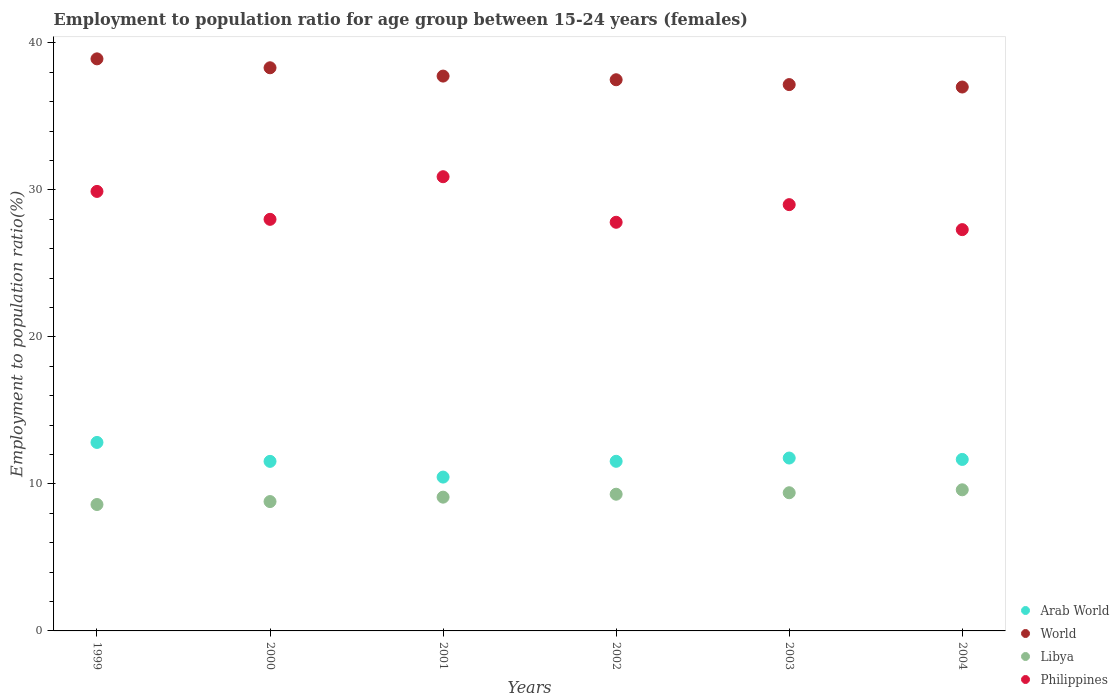Is the number of dotlines equal to the number of legend labels?
Give a very brief answer. Yes. What is the employment to population ratio in World in 2001?
Make the answer very short. 37.75. Across all years, what is the maximum employment to population ratio in Philippines?
Offer a very short reply. 30.9. Across all years, what is the minimum employment to population ratio in Philippines?
Make the answer very short. 27.3. In which year was the employment to population ratio in World maximum?
Your answer should be very brief. 1999. What is the total employment to population ratio in Libya in the graph?
Provide a short and direct response. 54.8. What is the difference between the employment to population ratio in Philippines in 2000 and that in 2004?
Offer a terse response. 0.7. What is the difference between the employment to population ratio in Libya in 2004 and the employment to population ratio in Philippines in 2003?
Give a very brief answer. -19.4. What is the average employment to population ratio in Arab World per year?
Your answer should be very brief. 11.63. In the year 2000, what is the difference between the employment to population ratio in World and employment to population ratio in Libya?
Offer a terse response. 29.51. In how many years, is the employment to population ratio in World greater than 4 %?
Keep it short and to the point. 6. What is the ratio of the employment to population ratio in Arab World in 2002 to that in 2004?
Your response must be concise. 0.99. Is the employment to population ratio in World in 1999 less than that in 2004?
Provide a succinct answer. No. Is the difference between the employment to population ratio in World in 1999 and 2004 greater than the difference between the employment to population ratio in Libya in 1999 and 2004?
Provide a succinct answer. Yes. What is the difference between the highest and the second highest employment to population ratio in World?
Keep it short and to the point. 0.61. What is the difference between the highest and the lowest employment to population ratio in Libya?
Give a very brief answer. 1. Is it the case that in every year, the sum of the employment to population ratio in Philippines and employment to population ratio in Libya  is greater than the employment to population ratio in World?
Offer a terse response. No. Does the employment to population ratio in Philippines monotonically increase over the years?
Ensure brevity in your answer.  No. Is the employment to population ratio in Libya strictly less than the employment to population ratio in World over the years?
Offer a very short reply. Yes. How many dotlines are there?
Ensure brevity in your answer.  4. Are the values on the major ticks of Y-axis written in scientific E-notation?
Keep it short and to the point. No. Does the graph contain any zero values?
Provide a short and direct response. No. Does the graph contain grids?
Provide a succinct answer. No. How many legend labels are there?
Provide a succinct answer. 4. What is the title of the graph?
Give a very brief answer. Employment to population ratio for age group between 15-24 years (females). What is the label or title of the X-axis?
Offer a very short reply. Years. What is the Employment to population ratio(%) in Arab World in 1999?
Ensure brevity in your answer.  12.82. What is the Employment to population ratio(%) of World in 1999?
Provide a succinct answer. 38.92. What is the Employment to population ratio(%) of Libya in 1999?
Ensure brevity in your answer.  8.6. What is the Employment to population ratio(%) of Philippines in 1999?
Your answer should be compact. 29.9. What is the Employment to population ratio(%) in Arab World in 2000?
Offer a terse response. 11.53. What is the Employment to population ratio(%) in World in 2000?
Your answer should be compact. 38.31. What is the Employment to population ratio(%) of Libya in 2000?
Provide a short and direct response. 8.8. What is the Employment to population ratio(%) in Philippines in 2000?
Keep it short and to the point. 28. What is the Employment to population ratio(%) in Arab World in 2001?
Make the answer very short. 10.47. What is the Employment to population ratio(%) in World in 2001?
Provide a succinct answer. 37.75. What is the Employment to population ratio(%) in Libya in 2001?
Your response must be concise. 9.1. What is the Employment to population ratio(%) in Philippines in 2001?
Offer a terse response. 30.9. What is the Employment to population ratio(%) in Arab World in 2002?
Give a very brief answer. 11.54. What is the Employment to population ratio(%) in World in 2002?
Offer a terse response. 37.5. What is the Employment to population ratio(%) of Libya in 2002?
Offer a very short reply. 9.3. What is the Employment to population ratio(%) of Philippines in 2002?
Offer a very short reply. 27.8. What is the Employment to population ratio(%) in Arab World in 2003?
Keep it short and to the point. 11.76. What is the Employment to population ratio(%) of World in 2003?
Keep it short and to the point. 37.17. What is the Employment to population ratio(%) of Libya in 2003?
Provide a succinct answer. 9.4. What is the Employment to population ratio(%) in Arab World in 2004?
Offer a terse response. 11.67. What is the Employment to population ratio(%) of World in 2004?
Provide a short and direct response. 37. What is the Employment to population ratio(%) in Libya in 2004?
Provide a short and direct response. 9.6. What is the Employment to population ratio(%) of Philippines in 2004?
Provide a succinct answer. 27.3. Across all years, what is the maximum Employment to population ratio(%) of Arab World?
Ensure brevity in your answer.  12.82. Across all years, what is the maximum Employment to population ratio(%) of World?
Provide a succinct answer. 38.92. Across all years, what is the maximum Employment to population ratio(%) in Libya?
Provide a succinct answer. 9.6. Across all years, what is the maximum Employment to population ratio(%) in Philippines?
Your response must be concise. 30.9. Across all years, what is the minimum Employment to population ratio(%) of Arab World?
Make the answer very short. 10.47. Across all years, what is the minimum Employment to population ratio(%) in World?
Your answer should be very brief. 37. Across all years, what is the minimum Employment to population ratio(%) of Libya?
Make the answer very short. 8.6. Across all years, what is the minimum Employment to population ratio(%) of Philippines?
Provide a succinct answer. 27.3. What is the total Employment to population ratio(%) of Arab World in the graph?
Your response must be concise. 69.79. What is the total Employment to population ratio(%) in World in the graph?
Make the answer very short. 226.64. What is the total Employment to population ratio(%) in Libya in the graph?
Ensure brevity in your answer.  54.8. What is the total Employment to population ratio(%) in Philippines in the graph?
Offer a very short reply. 172.9. What is the difference between the Employment to population ratio(%) of Arab World in 1999 and that in 2000?
Give a very brief answer. 1.29. What is the difference between the Employment to population ratio(%) in World in 1999 and that in 2000?
Your answer should be compact. 0.61. What is the difference between the Employment to population ratio(%) of Arab World in 1999 and that in 2001?
Your answer should be very brief. 2.36. What is the difference between the Employment to population ratio(%) in World in 1999 and that in 2001?
Your response must be concise. 1.17. What is the difference between the Employment to population ratio(%) of Arab World in 1999 and that in 2002?
Give a very brief answer. 1.28. What is the difference between the Employment to population ratio(%) of World in 1999 and that in 2002?
Offer a terse response. 1.42. What is the difference between the Employment to population ratio(%) in Libya in 1999 and that in 2002?
Ensure brevity in your answer.  -0.7. What is the difference between the Employment to population ratio(%) in Arab World in 1999 and that in 2003?
Ensure brevity in your answer.  1.06. What is the difference between the Employment to population ratio(%) of World in 1999 and that in 2003?
Keep it short and to the point. 1.75. What is the difference between the Employment to population ratio(%) of Arab World in 1999 and that in 2004?
Offer a terse response. 1.16. What is the difference between the Employment to population ratio(%) in World in 1999 and that in 2004?
Give a very brief answer. 1.92. What is the difference between the Employment to population ratio(%) of Libya in 1999 and that in 2004?
Your response must be concise. -1. What is the difference between the Employment to population ratio(%) in Arab World in 2000 and that in 2001?
Your response must be concise. 1.07. What is the difference between the Employment to population ratio(%) of World in 2000 and that in 2001?
Offer a very short reply. 0.57. What is the difference between the Employment to population ratio(%) of Arab World in 2000 and that in 2002?
Keep it short and to the point. -0. What is the difference between the Employment to population ratio(%) of World in 2000 and that in 2002?
Make the answer very short. 0.81. What is the difference between the Employment to population ratio(%) of Libya in 2000 and that in 2002?
Your response must be concise. -0.5. What is the difference between the Employment to population ratio(%) in Philippines in 2000 and that in 2002?
Provide a succinct answer. 0.2. What is the difference between the Employment to population ratio(%) of Arab World in 2000 and that in 2003?
Offer a terse response. -0.23. What is the difference between the Employment to population ratio(%) of World in 2000 and that in 2003?
Make the answer very short. 1.14. What is the difference between the Employment to population ratio(%) of Philippines in 2000 and that in 2003?
Offer a very short reply. -1. What is the difference between the Employment to population ratio(%) in Arab World in 2000 and that in 2004?
Ensure brevity in your answer.  -0.13. What is the difference between the Employment to population ratio(%) in World in 2000 and that in 2004?
Your answer should be compact. 1.31. What is the difference between the Employment to population ratio(%) in Libya in 2000 and that in 2004?
Give a very brief answer. -0.8. What is the difference between the Employment to population ratio(%) of Philippines in 2000 and that in 2004?
Your answer should be very brief. 0.7. What is the difference between the Employment to population ratio(%) of Arab World in 2001 and that in 2002?
Provide a succinct answer. -1.07. What is the difference between the Employment to population ratio(%) of World in 2001 and that in 2002?
Make the answer very short. 0.25. What is the difference between the Employment to population ratio(%) in Philippines in 2001 and that in 2002?
Make the answer very short. 3.1. What is the difference between the Employment to population ratio(%) in Arab World in 2001 and that in 2003?
Ensure brevity in your answer.  -1.3. What is the difference between the Employment to population ratio(%) of World in 2001 and that in 2003?
Make the answer very short. 0.58. What is the difference between the Employment to population ratio(%) in Libya in 2001 and that in 2003?
Your answer should be very brief. -0.3. What is the difference between the Employment to population ratio(%) in Philippines in 2001 and that in 2003?
Make the answer very short. 1.9. What is the difference between the Employment to population ratio(%) of Arab World in 2001 and that in 2004?
Offer a terse response. -1.2. What is the difference between the Employment to population ratio(%) in World in 2001 and that in 2004?
Keep it short and to the point. 0.74. What is the difference between the Employment to population ratio(%) of Philippines in 2001 and that in 2004?
Give a very brief answer. 3.6. What is the difference between the Employment to population ratio(%) in Arab World in 2002 and that in 2003?
Provide a short and direct response. -0.22. What is the difference between the Employment to population ratio(%) in World in 2002 and that in 2003?
Give a very brief answer. 0.33. What is the difference between the Employment to population ratio(%) in Libya in 2002 and that in 2003?
Ensure brevity in your answer.  -0.1. What is the difference between the Employment to population ratio(%) in Arab World in 2002 and that in 2004?
Give a very brief answer. -0.13. What is the difference between the Employment to population ratio(%) in World in 2002 and that in 2004?
Give a very brief answer. 0.49. What is the difference between the Employment to population ratio(%) in Libya in 2002 and that in 2004?
Make the answer very short. -0.3. What is the difference between the Employment to population ratio(%) in Arab World in 2003 and that in 2004?
Make the answer very short. 0.1. What is the difference between the Employment to population ratio(%) of World in 2003 and that in 2004?
Keep it short and to the point. 0.17. What is the difference between the Employment to population ratio(%) of Libya in 2003 and that in 2004?
Offer a terse response. -0.2. What is the difference between the Employment to population ratio(%) of Arab World in 1999 and the Employment to population ratio(%) of World in 2000?
Give a very brief answer. -25.49. What is the difference between the Employment to population ratio(%) in Arab World in 1999 and the Employment to population ratio(%) in Libya in 2000?
Offer a terse response. 4.02. What is the difference between the Employment to population ratio(%) in Arab World in 1999 and the Employment to population ratio(%) in Philippines in 2000?
Keep it short and to the point. -15.18. What is the difference between the Employment to population ratio(%) of World in 1999 and the Employment to population ratio(%) of Libya in 2000?
Keep it short and to the point. 30.12. What is the difference between the Employment to population ratio(%) in World in 1999 and the Employment to population ratio(%) in Philippines in 2000?
Offer a very short reply. 10.92. What is the difference between the Employment to population ratio(%) of Libya in 1999 and the Employment to population ratio(%) of Philippines in 2000?
Your answer should be very brief. -19.4. What is the difference between the Employment to population ratio(%) in Arab World in 1999 and the Employment to population ratio(%) in World in 2001?
Your response must be concise. -24.92. What is the difference between the Employment to population ratio(%) in Arab World in 1999 and the Employment to population ratio(%) in Libya in 2001?
Your answer should be compact. 3.72. What is the difference between the Employment to population ratio(%) in Arab World in 1999 and the Employment to population ratio(%) in Philippines in 2001?
Offer a very short reply. -18.08. What is the difference between the Employment to population ratio(%) of World in 1999 and the Employment to population ratio(%) of Libya in 2001?
Make the answer very short. 29.82. What is the difference between the Employment to population ratio(%) of World in 1999 and the Employment to population ratio(%) of Philippines in 2001?
Provide a short and direct response. 8.02. What is the difference between the Employment to population ratio(%) in Libya in 1999 and the Employment to population ratio(%) in Philippines in 2001?
Give a very brief answer. -22.3. What is the difference between the Employment to population ratio(%) of Arab World in 1999 and the Employment to population ratio(%) of World in 2002?
Your answer should be very brief. -24.67. What is the difference between the Employment to population ratio(%) of Arab World in 1999 and the Employment to population ratio(%) of Libya in 2002?
Make the answer very short. 3.52. What is the difference between the Employment to population ratio(%) of Arab World in 1999 and the Employment to population ratio(%) of Philippines in 2002?
Your answer should be compact. -14.98. What is the difference between the Employment to population ratio(%) of World in 1999 and the Employment to population ratio(%) of Libya in 2002?
Offer a terse response. 29.62. What is the difference between the Employment to population ratio(%) of World in 1999 and the Employment to population ratio(%) of Philippines in 2002?
Your answer should be very brief. 11.12. What is the difference between the Employment to population ratio(%) in Libya in 1999 and the Employment to population ratio(%) in Philippines in 2002?
Your answer should be very brief. -19.2. What is the difference between the Employment to population ratio(%) in Arab World in 1999 and the Employment to population ratio(%) in World in 2003?
Your answer should be compact. -24.34. What is the difference between the Employment to population ratio(%) of Arab World in 1999 and the Employment to population ratio(%) of Libya in 2003?
Make the answer very short. 3.42. What is the difference between the Employment to population ratio(%) in Arab World in 1999 and the Employment to population ratio(%) in Philippines in 2003?
Ensure brevity in your answer.  -16.18. What is the difference between the Employment to population ratio(%) in World in 1999 and the Employment to population ratio(%) in Libya in 2003?
Your response must be concise. 29.52. What is the difference between the Employment to population ratio(%) of World in 1999 and the Employment to population ratio(%) of Philippines in 2003?
Your answer should be very brief. 9.92. What is the difference between the Employment to population ratio(%) of Libya in 1999 and the Employment to population ratio(%) of Philippines in 2003?
Your response must be concise. -20.4. What is the difference between the Employment to population ratio(%) of Arab World in 1999 and the Employment to population ratio(%) of World in 2004?
Make the answer very short. -24.18. What is the difference between the Employment to population ratio(%) of Arab World in 1999 and the Employment to population ratio(%) of Libya in 2004?
Provide a succinct answer. 3.22. What is the difference between the Employment to population ratio(%) in Arab World in 1999 and the Employment to population ratio(%) in Philippines in 2004?
Offer a very short reply. -14.48. What is the difference between the Employment to population ratio(%) of World in 1999 and the Employment to population ratio(%) of Libya in 2004?
Offer a terse response. 29.32. What is the difference between the Employment to population ratio(%) in World in 1999 and the Employment to population ratio(%) in Philippines in 2004?
Provide a succinct answer. 11.62. What is the difference between the Employment to population ratio(%) in Libya in 1999 and the Employment to population ratio(%) in Philippines in 2004?
Give a very brief answer. -18.7. What is the difference between the Employment to population ratio(%) of Arab World in 2000 and the Employment to population ratio(%) of World in 2001?
Ensure brevity in your answer.  -26.21. What is the difference between the Employment to population ratio(%) of Arab World in 2000 and the Employment to population ratio(%) of Libya in 2001?
Your answer should be very brief. 2.43. What is the difference between the Employment to population ratio(%) in Arab World in 2000 and the Employment to population ratio(%) in Philippines in 2001?
Make the answer very short. -19.37. What is the difference between the Employment to population ratio(%) in World in 2000 and the Employment to population ratio(%) in Libya in 2001?
Offer a very short reply. 29.21. What is the difference between the Employment to population ratio(%) in World in 2000 and the Employment to population ratio(%) in Philippines in 2001?
Give a very brief answer. 7.41. What is the difference between the Employment to population ratio(%) of Libya in 2000 and the Employment to population ratio(%) of Philippines in 2001?
Your answer should be very brief. -22.1. What is the difference between the Employment to population ratio(%) of Arab World in 2000 and the Employment to population ratio(%) of World in 2002?
Give a very brief answer. -25.96. What is the difference between the Employment to population ratio(%) of Arab World in 2000 and the Employment to population ratio(%) of Libya in 2002?
Your answer should be very brief. 2.23. What is the difference between the Employment to population ratio(%) of Arab World in 2000 and the Employment to population ratio(%) of Philippines in 2002?
Offer a very short reply. -16.27. What is the difference between the Employment to population ratio(%) of World in 2000 and the Employment to population ratio(%) of Libya in 2002?
Provide a short and direct response. 29.01. What is the difference between the Employment to population ratio(%) of World in 2000 and the Employment to population ratio(%) of Philippines in 2002?
Provide a short and direct response. 10.51. What is the difference between the Employment to population ratio(%) in Libya in 2000 and the Employment to population ratio(%) in Philippines in 2002?
Offer a terse response. -19. What is the difference between the Employment to population ratio(%) of Arab World in 2000 and the Employment to population ratio(%) of World in 2003?
Your answer should be compact. -25.63. What is the difference between the Employment to population ratio(%) of Arab World in 2000 and the Employment to population ratio(%) of Libya in 2003?
Your answer should be compact. 2.13. What is the difference between the Employment to population ratio(%) of Arab World in 2000 and the Employment to population ratio(%) of Philippines in 2003?
Your response must be concise. -17.47. What is the difference between the Employment to population ratio(%) in World in 2000 and the Employment to population ratio(%) in Libya in 2003?
Make the answer very short. 28.91. What is the difference between the Employment to population ratio(%) in World in 2000 and the Employment to population ratio(%) in Philippines in 2003?
Ensure brevity in your answer.  9.31. What is the difference between the Employment to population ratio(%) of Libya in 2000 and the Employment to population ratio(%) of Philippines in 2003?
Give a very brief answer. -20.2. What is the difference between the Employment to population ratio(%) of Arab World in 2000 and the Employment to population ratio(%) of World in 2004?
Give a very brief answer. -25.47. What is the difference between the Employment to population ratio(%) of Arab World in 2000 and the Employment to population ratio(%) of Libya in 2004?
Give a very brief answer. 1.93. What is the difference between the Employment to population ratio(%) in Arab World in 2000 and the Employment to population ratio(%) in Philippines in 2004?
Provide a short and direct response. -15.77. What is the difference between the Employment to population ratio(%) of World in 2000 and the Employment to population ratio(%) of Libya in 2004?
Provide a short and direct response. 28.71. What is the difference between the Employment to population ratio(%) in World in 2000 and the Employment to population ratio(%) in Philippines in 2004?
Keep it short and to the point. 11.01. What is the difference between the Employment to population ratio(%) in Libya in 2000 and the Employment to population ratio(%) in Philippines in 2004?
Give a very brief answer. -18.5. What is the difference between the Employment to population ratio(%) of Arab World in 2001 and the Employment to population ratio(%) of World in 2002?
Provide a short and direct response. -27.03. What is the difference between the Employment to population ratio(%) in Arab World in 2001 and the Employment to population ratio(%) in Libya in 2002?
Make the answer very short. 1.17. What is the difference between the Employment to population ratio(%) in Arab World in 2001 and the Employment to population ratio(%) in Philippines in 2002?
Give a very brief answer. -17.33. What is the difference between the Employment to population ratio(%) of World in 2001 and the Employment to population ratio(%) of Libya in 2002?
Your answer should be very brief. 28.45. What is the difference between the Employment to population ratio(%) of World in 2001 and the Employment to population ratio(%) of Philippines in 2002?
Make the answer very short. 9.95. What is the difference between the Employment to population ratio(%) in Libya in 2001 and the Employment to population ratio(%) in Philippines in 2002?
Your response must be concise. -18.7. What is the difference between the Employment to population ratio(%) in Arab World in 2001 and the Employment to population ratio(%) in World in 2003?
Keep it short and to the point. -26.7. What is the difference between the Employment to population ratio(%) of Arab World in 2001 and the Employment to population ratio(%) of Libya in 2003?
Give a very brief answer. 1.07. What is the difference between the Employment to population ratio(%) in Arab World in 2001 and the Employment to population ratio(%) in Philippines in 2003?
Your answer should be very brief. -18.53. What is the difference between the Employment to population ratio(%) of World in 2001 and the Employment to population ratio(%) of Libya in 2003?
Give a very brief answer. 28.35. What is the difference between the Employment to population ratio(%) in World in 2001 and the Employment to population ratio(%) in Philippines in 2003?
Ensure brevity in your answer.  8.75. What is the difference between the Employment to population ratio(%) of Libya in 2001 and the Employment to population ratio(%) of Philippines in 2003?
Make the answer very short. -19.9. What is the difference between the Employment to population ratio(%) in Arab World in 2001 and the Employment to population ratio(%) in World in 2004?
Your answer should be compact. -26.54. What is the difference between the Employment to population ratio(%) of Arab World in 2001 and the Employment to population ratio(%) of Libya in 2004?
Ensure brevity in your answer.  0.87. What is the difference between the Employment to population ratio(%) of Arab World in 2001 and the Employment to population ratio(%) of Philippines in 2004?
Offer a very short reply. -16.83. What is the difference between the Employment to population ratio(%) in World in 2001 and the Employment to population ratio(%) in Libya in 2004?
Your answer should be compact. 28.15. What is the difference between the Employment to population ratio(%) of World in 2001 and the Employment to population ratio(%) of Philippines in 2004?
Give a very brief answer. 10.45. What is the difference between the Employment to population ratio(%) of Libya in 2001 and the Employment to population ratio(%) of Philippines in 2004?
Offer a very short reply. -18.2. What is the difference between the Employment to population ratio(%) in Arab World in 2002 and the Employment to population ratio(%) in World in 2003?
Offer a very short reply. -25.63. What is the difference between the Employment to population ratio(%) of Arab World in 2002 and the Employment to population ratio(%) of Libya in 2003?
Offer a very short reply. 2.14. What is the difference between the Employment to population ratio(%) in Arab World in 2002 and the Employment to population ratio(%) in Philippines in 2003?
Your response must be concise. -17.46. What is the difference between the Employment to population ratio(%) of World in 2002 and the Employment to population ratio(%) of Libya in 2003?
Provide a succinct answer. 28.1. What is the difference between the Employment to population ratio(%) in World in 2002 and the Employment to population ratio(%) in Philippines in 2003?
Make the answer very short. 8.5. What is the difference between the Employment to population ratio(%) of Libya in 2002 and the Employment to population ratio(%) of Philippines in 2003?
Make the answer very short. -19.7. What is the difference between the Employment to population ratio(%) of Arab World in 2002 and the Employment to population ratio(%) of World in 2004?
Offer a terse response. -25.46. What is the difference between the Employment to population ratio(%) in Arab World in 2002 and the Employment to population ratio(%) in Libya in 2004?
Offer a very short reply. 1.94. What is the difference between the Employment to population ratio(%) in Arab World in 2002 and the Employment to population ratio(%) in Philippines in 2004?
Provide a succinct answer. -15.76. What is the difference between the Employment to population ratio(%) of World in 2002 and the Employment to population ratio(%) of Libya in 2004?
Your answer should be very brief. 27.9. What is the difference between the Employment to population ratio(%) of World in 2002 and the Employment to population ratio(%) of Philippines in 2004?
Provide a short and direct response. 10.2. What is the difference between the Employment to population ratio(%) of Arab World in 2003 and the Employment to population ratio(%) of World in 2004?
Your answer should be compact. -25.24. What is the difference between the Employment to population ratio(%) of Arab World in 2003 and the Employment to population ratio(%) of Libya in 2004?
Provide a succinct answer. 2.16. What is the difference between the Employment to population ratio(%) in Arab World in 2003 and the Employment to population ratio(%) in Philippines in 2004?
Offer a terse response. -15.54. What is the difference between the Employment to population ratio(%) in World in 2003 and the Employment to population ratio(%) in Libya in 2004?
Your response must be concise. 27.57. What is the difference between the Employment to population ratio(%) in World in 2003 and the Employment to population ratio(%) in Philippines in 2004?
Make the answer very short. 9.87. What is the difference between the Employment to population ratio(%) of Libya in 2003 and the Employment to population ratio(%) of Philippines in 2004?
Make the answer very short. -17.9. What is the average Employment to population ratio(%) in Arab World per year?
Provide a short and direct response. 11.63. What is the average Employment to population ratio(%) in World per year?
Your answer should be very brief. 37.77. What is the average Employment to population ratio(%) of Libya per year?
Offer a terse response. 9.13. What is the average Employment to population ratio(%) in Philippines per year?
Make the answer very short. 28.82. In the year 1999, what is the difference between the Employment to population ratio(%) in Arab World and Employment to population ratio(%) in World?
Your answer should be very brief. -26.1. In the year 1999, what is the difference between the Employment to population ratio(%) of Arab World and Employment to population ratio(%) of Libya?
Keep it short and to the point. 4.22. In the year 1999, what is the difference between the Employment to population ratio(%) of Arab World and Employment to population ratio(%) of Philippines?
Keep it short and to the point. -17.08. In the year 1999, what is the difference between the Employment to population ratio(%) in World and Employment to population ratio(%) in Libya?
Your answer should be very brief. 30.32. In the year 1999, what is the difference between the Employment to population ratio(%) in World and Employment to population ratio(%) in Philippines?
Offer a terse response. 9.02. In the year 1999, what is the difference between the Employment to population ratio(%) in Libya and Employment to population ratio(%) in Philippines?
Ensure brevity in your answer.  -21.3. In the year 2000, what is the difference between the Employment to population ratio(%) of Arab World and Employment to population ratio(%) of World?
Keep it short and to the point. -26.78. In the year 2000, what is the difference between the Employment to population ratio(%) of Arab World and Employment to population ratio(%) of Libya?
Keep it short and to the point. 2.73. In the year 2000, what is the difference between the Employment to population ratio(%) in Arab World and Employment to population ratio(%) in Philippines?
Offer a very short reply. -16.47. In the year 2000, what is the difference between the Employment to population ratio(%) in World and Employment to population ratio(%) in Libya?
Your answer should be compact. 29.51. In the year 2000, what is the difference between the Employment to population ratio(%) of World and Employment to population ratio(%) of Philippines?
Give a very brief answer. 10.31. In the year 2000, what is the difference between the Employment to population ratio(%) of Libya and Employment to population ratio(%) of Philippines?
Make the answer very short. -19.2. In the year 2001, what is the difference between the Employment to population ratio(%) in Arab World and Employment to population ratio(%) in World?
Offer a very short reply. -27.28. In the year 2001, what is the difference between the Employment to population ratio(%) of Arab World and Employment to population ratio(%) of Libya?
Your answer should be compact. 1.37. In the year 2001, what is the difference between the Employment to population ratio(%) of Arab World and Employment to population ratio(%) of Philippines?
Make the answer very short. -20.43. In the year 2001, what is the difference between the Employment to population ratio(%) of World and Employment to population ratio(%) of Libya?
Provide a succinct answer. 28.65. In the year 2001, what is the difference between the Employment to population ratio(%) of World and Employment to population ratio(%) of Philippines?
Your response must be concise. 6.85. In the year 2001, what is the difference between the Employment to population ratio(%) of Libya and Employment to population ratio(%) of Philippines?
Keep it short and to the point. -21.8. In the year 2002, what is the difference between the Employment to population ratio(%) in Arab World and Employment to population ratio(%) in World?
Your answer should be very brief. -25.96. In the year 2002, what is the difference between the Employment to population ratio(%) in Arab World and Employment to population ratio(%) in Libya?
Give a very brief answer. 2.24. In the year 2002, what is the difference between the Employment to population ratio(%) of Arab World and Employment to population ratio(%) of Philippines?
Give a very brief answer. -16.26. In the year 2002, what is the difference between the Employment to population ratio(%) of World and Employment to population ratio(%) of Libya?
Ensure brevity in your answer.  28.2. In the year 2002, what is the difference between the Employment to population ratio(%) in World and Employment to population ratio(%) in Philippines?
Your response must be concise. 9.7. In the year 2002, what is the difference between the Employment to population ratio(%) in Libya and Employment to population ratio(%) in Philippines?
Make the answer very short. -18.5. In the year 2003, what is the difference between the Employment to population ratio(%) of Arab World and Employment to population ratio(%) of World?
Keep it short and to the point. -25.41. In the year 2003, what is the difference between the Employment to population ratio(%) of Arab World and Employment to population ratio(%) of Libya?
Your answer should be compact. 2.36. In the year 2003, what is the difference between the Employment to population ratio(%) of Arab World and Employment to population ratio(%) of Philippines?
Provide a succinct answer. -17.24. In the year 2003, what is the difference between the Employment to population ratio(%) of World and Employment to population ratio(%) of Libya?
Your response must be concise. 27.77. In the year 2003, what is the difference between the Employment to population ratio(%) of World and Employment to population ratio(%) of Philippines?
Your response must be concise. 8.17. In the year 2003, what is the difference between the Employment to population ratio(%) of Libya and Employment to population ratio(%) of Philippines?
Your answer should be very brief. -19.6. In the year 2004, what is the difference between the Employment to population ratio(%) in Arab World and Employment to population ratio(%) in World?
Ensure brevity in your answer.  -25.34. In the year 2004, what is the difference between the Employment to population ratio(%) of Arab World and Employment to population ratio(%) of Libya?
Offer a very short reply. 2.07. In the year 2004, what is the difference between the Employment to population ratio(%) of Arab World and Employment to population ratio(%) of Philippines?
Give a very brief answer. -15.63. In the year 2004, what is the difference between the Employment to population ratio(%) in World and Employment to population ratio(%) in Libya?
Provide a succinct answer. 27.4. In the year 2004, what is the difference between the Employment to population ratio(%) of World and Employment to population ratio(%) of Philippines?
Your answer should be very brief. 9.7. In the year 2004, what is the difference between the Employment to population ratio(%) of Libya and Employment to population ratio(%) of Philippines?
Make the answer very short. -17.7. What is the ratio of the Employment to population ratio(%) of Arab World in 1999 to that in 2000?
Ensure brevity in your answer.  1.11. What is the ratio of the Employment to population ratio(%) of World in 1999 to that in 2000?
Ensure brevity in your answer.  1.02. What is the ratio of the Employment to population ratio(%) in Libya in 1999 to that in 2000?
Make the answer very short. 0.98. What is the ratio of the Employment to population ratio(%) of Philippines in 1999 to that in 2000?
Your answer should be compact. 1.07. What is the ratio of the Employment to population ratio(%) of Arab World in 1999 to that in 2001?
Give a very brief answer. 1.23. What is the ratio of the Employment to population ratio(%) in World in 1999 to that in 2001?
Give a very brief answer. 1.03. What is the ratio of the Employment to population ratio(%) in Libya in 1999 to that in 2001?
Ensure brevity in your answer.  0.95. What is the ratio of the Employment to population ratio(%) of Philippines in 1999 to that in 2001?
Offer a terse response. 0.97. What is the ratio of the Employment to population ratio(%) in Arab World in 1999 to that in 2002?
Your answer should be very brief. 1.11. What is the ratio of the Employment to population ratio(%) of World in 1999 to that in 2002?
Your response must be concise. 1.04. What is the ratio of the Employment to population ratio(%) in Libya in 1999 to that in 2002?
Offer a terse response. 0.92. What is the ratio of the Employment to population ratio(%) in Philippines in 1999 to that in 2002?
Make the answer very short. 1.08. What is the ratio of the Employment to population ratio(%) of Arab World in 1999 to that in 2003?
Give a very brief answer. 1.09. What is the ratio of the Employment to population ratio(%) of World in 1999 to that in 2003?
Your answer should be very brief. 1.05. What is the ratio of the Employment to population ratio(%) of Libya in 1999 to that in 2003?
Provide a short and direct response. 0.91. What is the ratio of the Employment to population ratio(%) of Philippines in 1999 to that in 2003?
Your answer should be compact. 1.03. What is the ratio of the Employment to population ratio(%) of Arab World in 1999 to that in 2004?
Make the answer very short. 1.1. What is the ratio of the Employment to population ratio(%) of World in 1999 to that in 2004?
Your answer should be compact. 1.05. What is the ratio of the Employment to population ratio(%) in Libya in 1999 to that in 2004?
Your response must be concise. 0.9. What is the ratio of the Employment to population ratio(%) of Philippines in 1999 to that in 2004?
Provide a short and direct response. 1.1. What is the ratio of the Employment to population ratio(%) of Arab World in 2000 to that in 2001?
Give a very brief answer. 1.1. What is the ratio of the Employment to population ratio(%) of World in 2000 to that in 2001?
Your answer should be very brief. 1.01. What is the ratio of the Employment to population ratio(%) in Philippines in 2000 to that in 2001?
Ensure brevity in your answer.  0.91. What is the ratio of the Employment to population ratio(%) of Arab World in 2000 to that in 2002?
Give a very brief answer. 1. What is the ratio of the Employment to population ratio(%) in World in 2000 to that in 2002?
Make the answer very short. 1.02. What is the ratio of the Employment to population ratio(%) of Libya in 2000 to that in 2002?
Your answer should be compact. 0.95. What is the ratio of the Employment to population ratio(%) of Arab World in 2000 to that in 2003?
Make the answer very short. 0.98. What is the ratio of the Employment to population ratio(%) of World in 2000 to that in 2003?
Keep it short and to the point. 1.03. What is the ratio of the Employment to population ratio(%) of Libya in 2000 to that in 2003?
Your answer should be compact. 0.94. What is the ratio of the Employment to population ratio(%) of Philippines in 2000 to that in 2003?
Make the answer very short. 0.97. What is the ratio of the Employment to population ratio(%) in Arab World in 2000 to that in 2004?
Your answer should be compact. 0.99. What is the ratio of the Employment to population ratio(%) of World in 2000 to that in 2004?
Make the answer very short. 1.04. What is the ratio of the Employment to population ratio(%) in Philippines in 2000 to that in 2004?
Offer a terse response. 1.03. What is the ratio of the Employment to population ratio(%) in Arab World in 2001 to that in 2002?
Your response must be concise. 0.91. What is the ratio of the Employment to population ratio(%) of World in 2001 to that in 2002?
Offer a very short reply. 1.01. What is the ratio of the Employment to population ratio(%) in Libya in 2001 to that in 2002?
Your answer should be very brief. 0.98. What is the ratio of the Employment to population ratio(%) of Philippines in 2001 to that in 2002?
Provide a succinct answer. 1.11. What is the ratio of the Employment to population ratio(%) of Arab World in 2001 to that in 2003?
Your answer should be very brief. 0.89. What is the ratio of the Employment to population ratio(%) of World in 2001 to that in 2003?
Provide a short and direct response. 1.02. What is the ratio of the Employment to population ratio(%) in Libya in 2001 to that in 2003?
Keep it short and to the point. 0.97. What is the ratio of the Employment to population ratio(%) of Philippines in 2001 to that in 2003?
Offer a terse response. 1.07. What is the ratio of the Employment to population ratio(%) of Arab World in 2001 to that in 2004?
Your response must be concise. 0.9. What is the ratio of the Employment to population ratio(%) in World in 2001 to that in 2004?
Your answer should be very brief. 1.02. What is the ratio of the Employment to population ratio(%) of Libya in 2001 to that in 2004?
Give a very brief answer. 0.95. What is the ratio of the Employment to population ratio(%) of Philippines in 2001 to that in 2004?
Offer a terse response. 1.13. What is the ratio of the Employment to population ratio(%) of Arab World in 2002 to that in 2003?
Provide a short and direct response. 0.98. What is the ratio of the Employment to population ratio(%) of World in 2002 to that in 2003?
Offer a terse response. 1.01. What is the ratio of the Employment to population ratio(%) in Philippines in 2002 to that in 2003?
Keep it short and to the point. 0.96. What is the ratio of the Employment to population ratio(%) in Arab World in 2002 to that in 2004?
Your answer should be compact. 0.99. What is the ratio of the Employment to population ratio(%) in World in 2002 to that in 2004?
Your answer should be compact. 1.01. What is the ratio of the Employment to population ratio(%) of Libya in 2002 to that in 2004?
Your response must be concise. 0.97. What is the ratio of the Employment to population ratio(%) of Philippines in 2002 to that in 2004?
Give a very brief answer. 1.02. What is the ratio of the Employment to population ratio(%) in Arab World in 2003 to that in 2004?
Make the answer very short. 1.01. What is the ratio of the Employment to population ratio(%) in Libya in 2003 to that in 2004?
Your answer should be compact. 0.98. What is the ratio of the Employment to population ratio(%) in Philippines in 2003 to that in 2004?
Give a very brief answer. 1.06. What is the difference between the highest and the second highest Employment to population ratio(%) of Arab World?
Give a very brief answer. 1.06. What is the difference between the highest and the second highest Employment to population ratio(%) of World?
Your response must be concise. 0.61. What is the difference between the highest and the second highest Employment to population ratio(%) in Philippines?
Your response must be concise. 1. What is the difference between the highest and the lowest Employment to population ratio(%) in Arab World?
Your answer should be compact. 2.36. What is the difference between the highest and the lowest Employment to population ratio(%) of World?
Your answer should be compact. 1.92. What is the difference between the highest and the lowest Employment to population ratio(%) in Libya?
Provide a short and direct response. 1. 